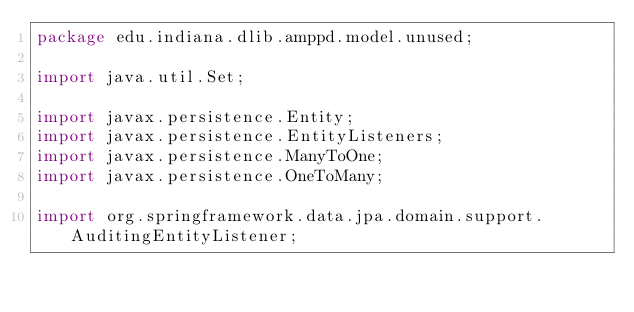<code> <loc_0><loc_0><loc_500><loc_500><_Java_>package edu.indiana.dlib.amppd.model.unused;

import java.util.Set;

import javax.persistence.Entity;
import javax.persistence.EntityListeners;
import javax.persistence.ManyToOne;
import javax.persistence.OneToMany;

import org.springframework.data.jpa.domain.support.AuditingEntityListener;
</code> 